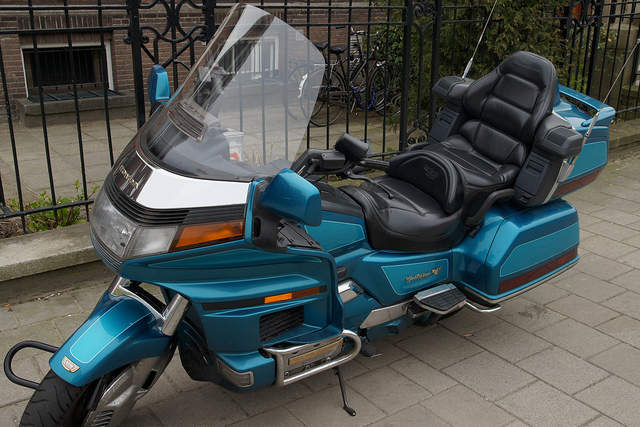How many people can ride this motorcycle at a time?
A. three
B. one
C. four
D. two
Answer with the option's letter from the given choices directly. D 